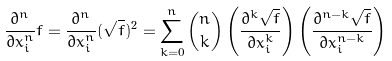Convert formula to latex. <formula><loc_0><loc_0><loc_500><loc_500>\frac { \partial ^ { n } } { \partial x _ { i } ^ { n } } f = \frac { \partial ^ { n } } { \partial x _ { i } ^ { n } } ( \sqrt { f } ) ^ { 2 } = \sum _ { k = 0 } ^ { n } { n \choose k } \left ( \frac { \partial ^ { k } \sqrt { f } } { \partial x _ { i } ^ { k } } \right ) \left ( \frac { \partial ^ { n - k } \sqrt { f } } { \partial x _ { i } ^ { n - k } } \right )</formula> 